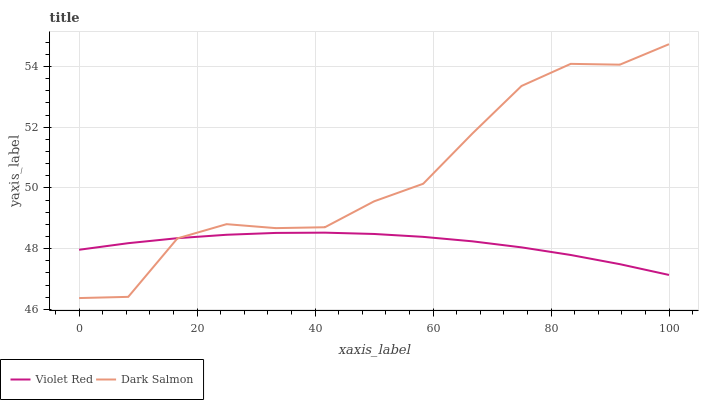Does Dark Salmon have the minimum area under the curve?
Answer yes or no. No. Is Dark Salmon the smoothest?
Answer yes or no. No. 